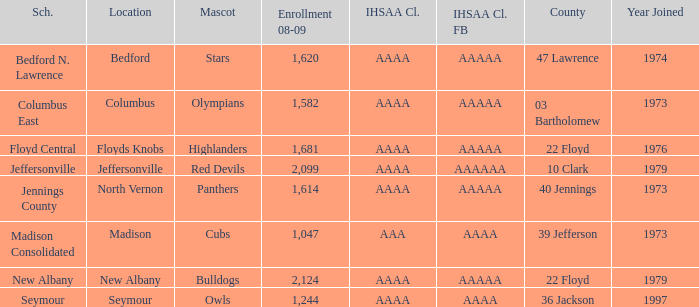What's the IHSAA Class Football if the panthers are the mascot? AAAAA. 